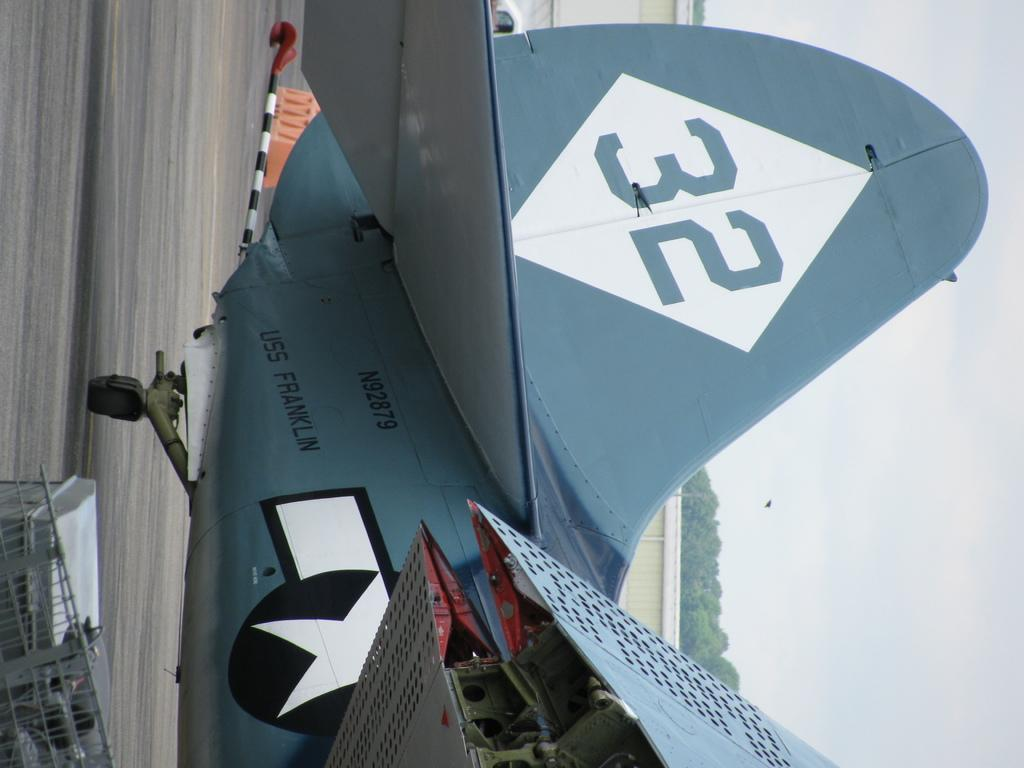Provide a one-sentence caption for the provided image. the USS franklin is a blue plane with the number 32 on its tail. 